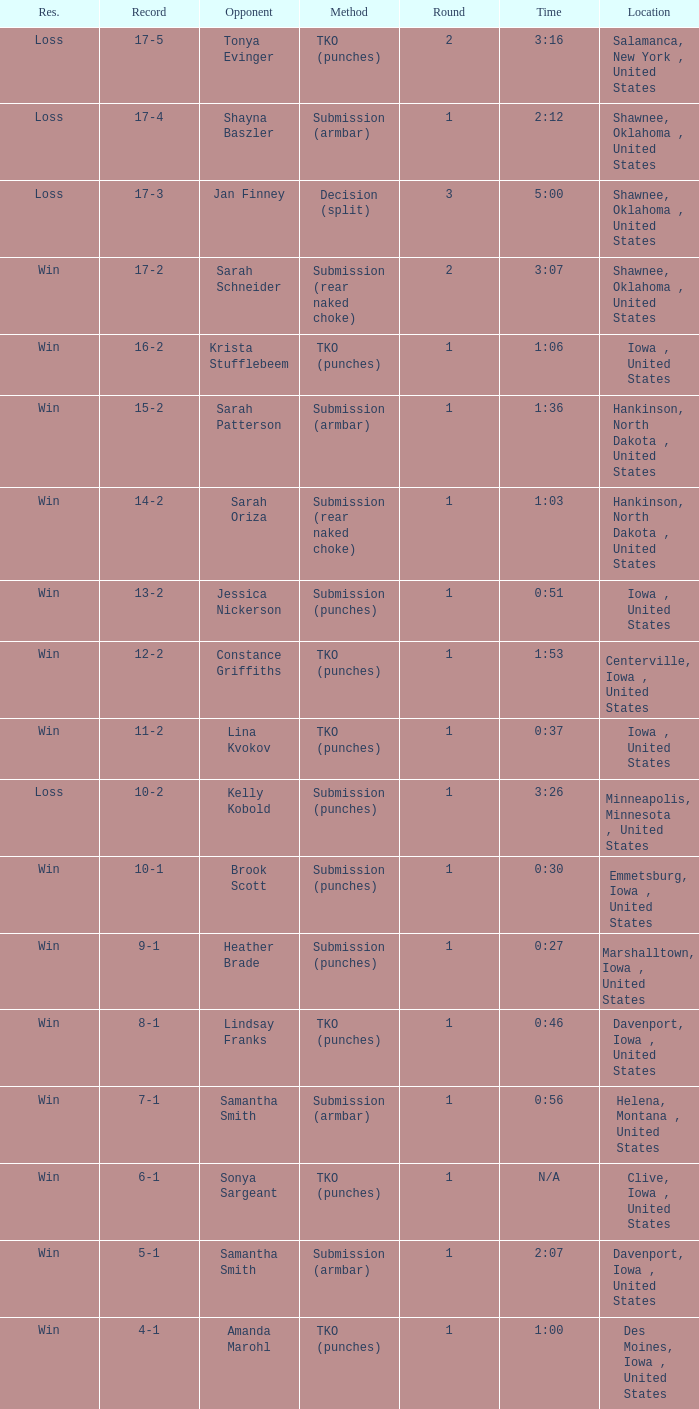What is the maximum number of rounds in a 3-minute, 16-second fight? 2.0. 